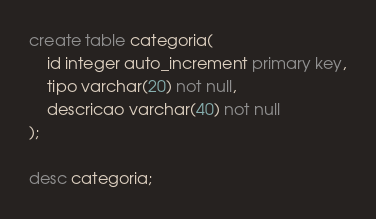Convert code to text. <code><loc_0><loc_0><loc_500><loc_500><_SQL_>create table categoria(
    id integer auto_increment primary key,
    tipo varchar(20) not null,
    descricao varchar(40) not null
);

desc categoria;
</code> 